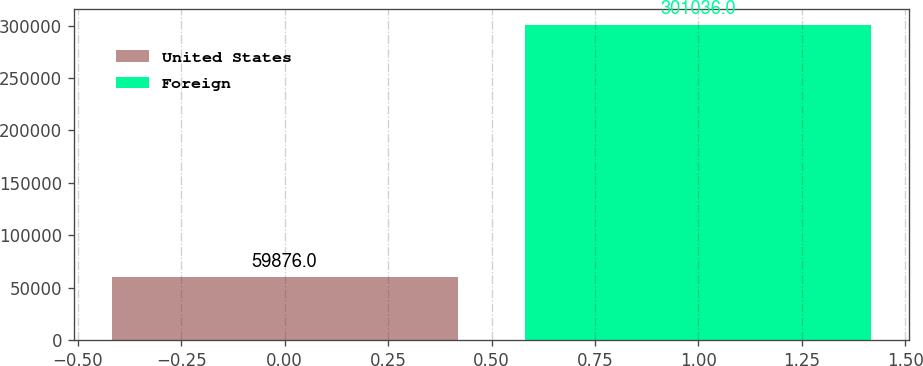<chart> <loc_0><loc_0><loc_500><loc_500><bar_chart><fcel>United States<fcel>Foreign<nl><fcel>59876<fcel>301036<nl></chart> 